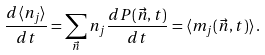Convert formula to latex. <formula><loc_0><loc_0><loc_500><loc_500>\frac { d \langle n _ { j } \rangle } { d t } = \sum _ { \vec { n } } n _ { j } \frac { d P ( \vec { n } , t ) } { d t } = \langle m _ { j } ( \vec { n } , t ) \rangle \, .</formula> 